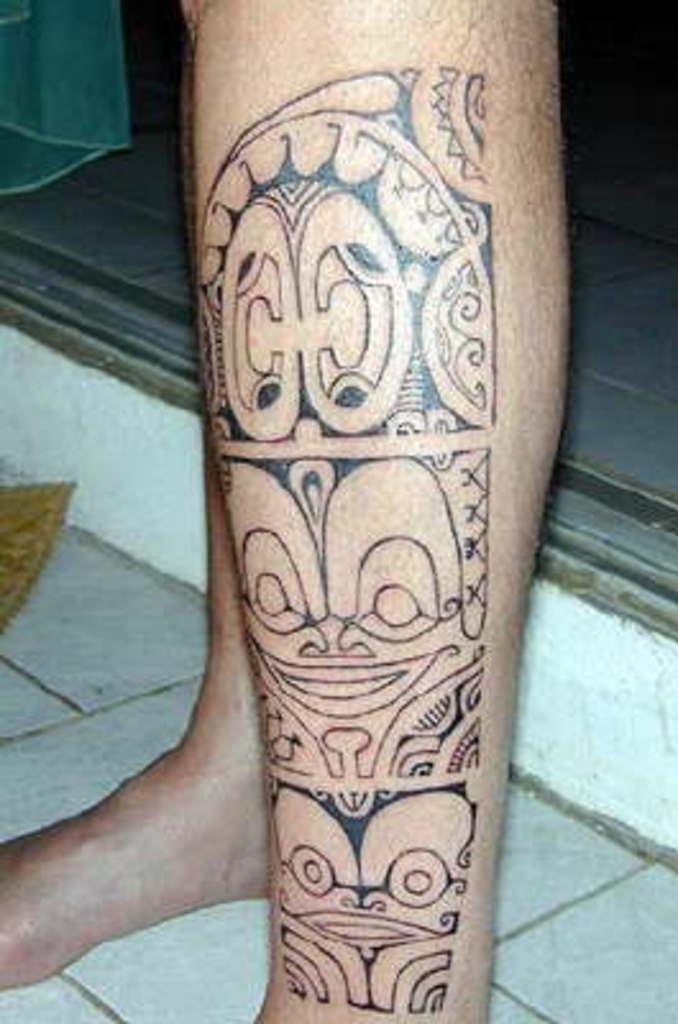Describe this image in one or two sentences. In this image I can see person's legs, one of the leg there is a art visible in front of the sill. 